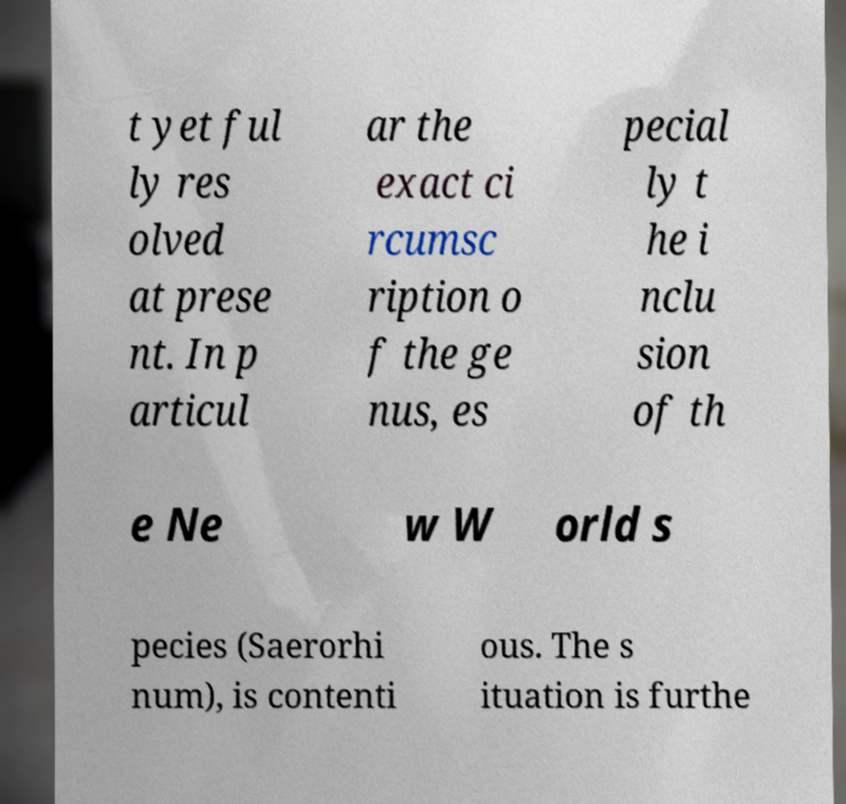I need the written content from this picture converted into text. Can you do that? t yet ful ly res olved at prese nt. In p articul ar the exact ci rcumsc ription o f the ge nus, es pecial ly t he i nclu sion of th e Ne w W orld s pecies (Saerorhi num), is contenti ous. The s ituation is furthe 